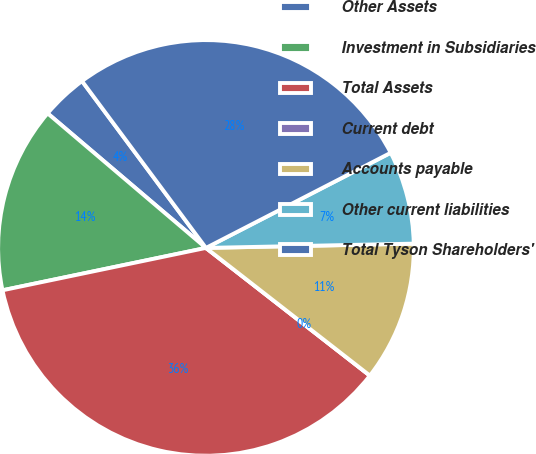<chart> <loc_0><loc_0><loc_500><loc_500><pie_chart><fcel>Other Assets<fcel>Investment in Subsidiaries<fcel>Total Assets<fcel>Current debt<fcel>Accounts payable<fcel>Other current liabilities<fcel>Total Tyson Shareholders'<nl><fcel>3.62%<fcel>14.48%<fcel>36.2%<fcel>0.0%<fcel>10.86%<fcel>7.24%<fcel>27.6%<nl></chart> 